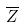Convert formula to latex. <formula><loc_0><loc_0><loc_500><loc_500>\overline { Z }</formula> 